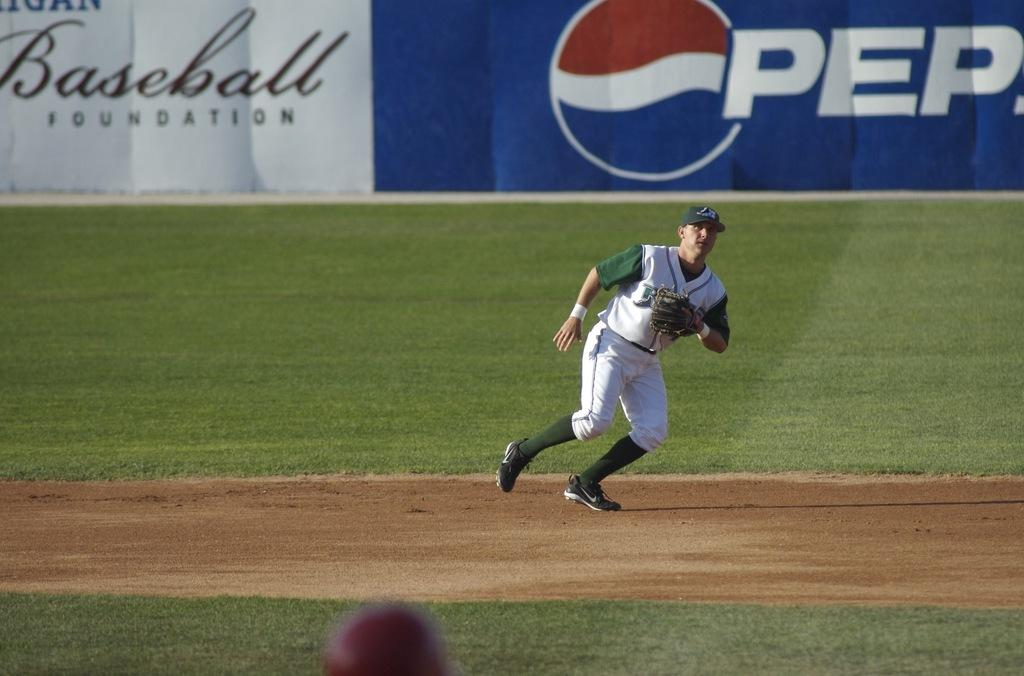<image>
Provide a brief description of the given image. A man in a baseball uniform on a field with Pepsi behind him 